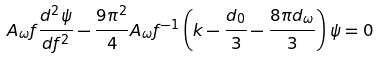<formula> <loc_0><loc_0><loc_500><loc_500>A _ { \omega } f \frac { d ^ { 2 } \psi } { d f ^ { 2 } } - \frac { 9 \pi ^ { 2 } } { 4 } A _ { \omega } f ^ { - 1 } \left ( k - \frac { d _ { 0 } } { 3 } - \frac { 8 \pi d _ { \omega } } { 3 } \right ) \psi = 0</formula> 